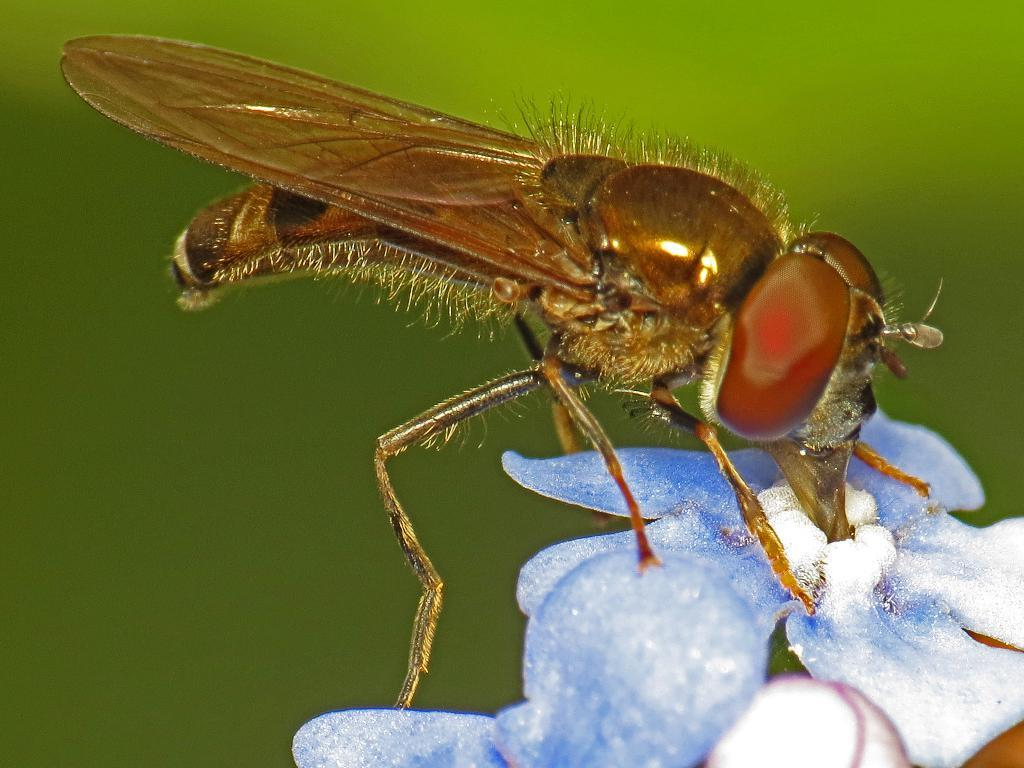What is the main subject of the image? There is a fly on flowers in the image. What color is the background of the image? The background of the image is green. Can you tell if the image was taken during the day or night? The image was likely taken during the day. What language is the fly speaking in the image? Flies do not speak any language, and there is no indication in the image that the fly is communicating verbally. 